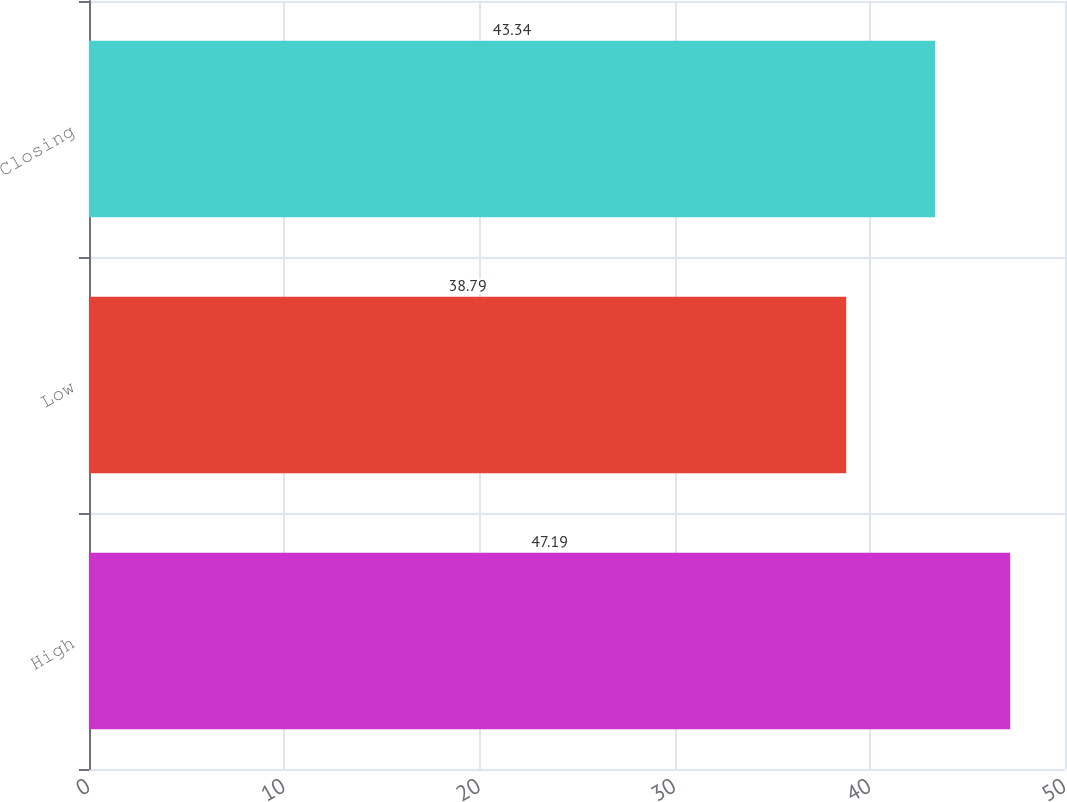Convert chart to OTSL. <chart><loc_0><loc_0><loc_500><loc_500><bar_chart><fcel>High<fcel>Low<fcel>Closing<nl><fcel>47.19<fcel>38.79<fcel>43.34<nl></chart> 